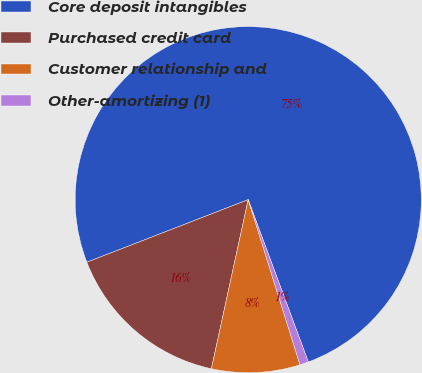<chart> <loc_0><loc_0><loc_500><loc_500><pie_chart><fcel>Core deposit intangibles<fcel>Purchased credit card<fcel>Customer relationship and<fcel>Other-amortizing (1)<nl><fcel>75.25%<fcel>15.7%<fcel>8.25%<fcel>0.81%<nl></chart> 